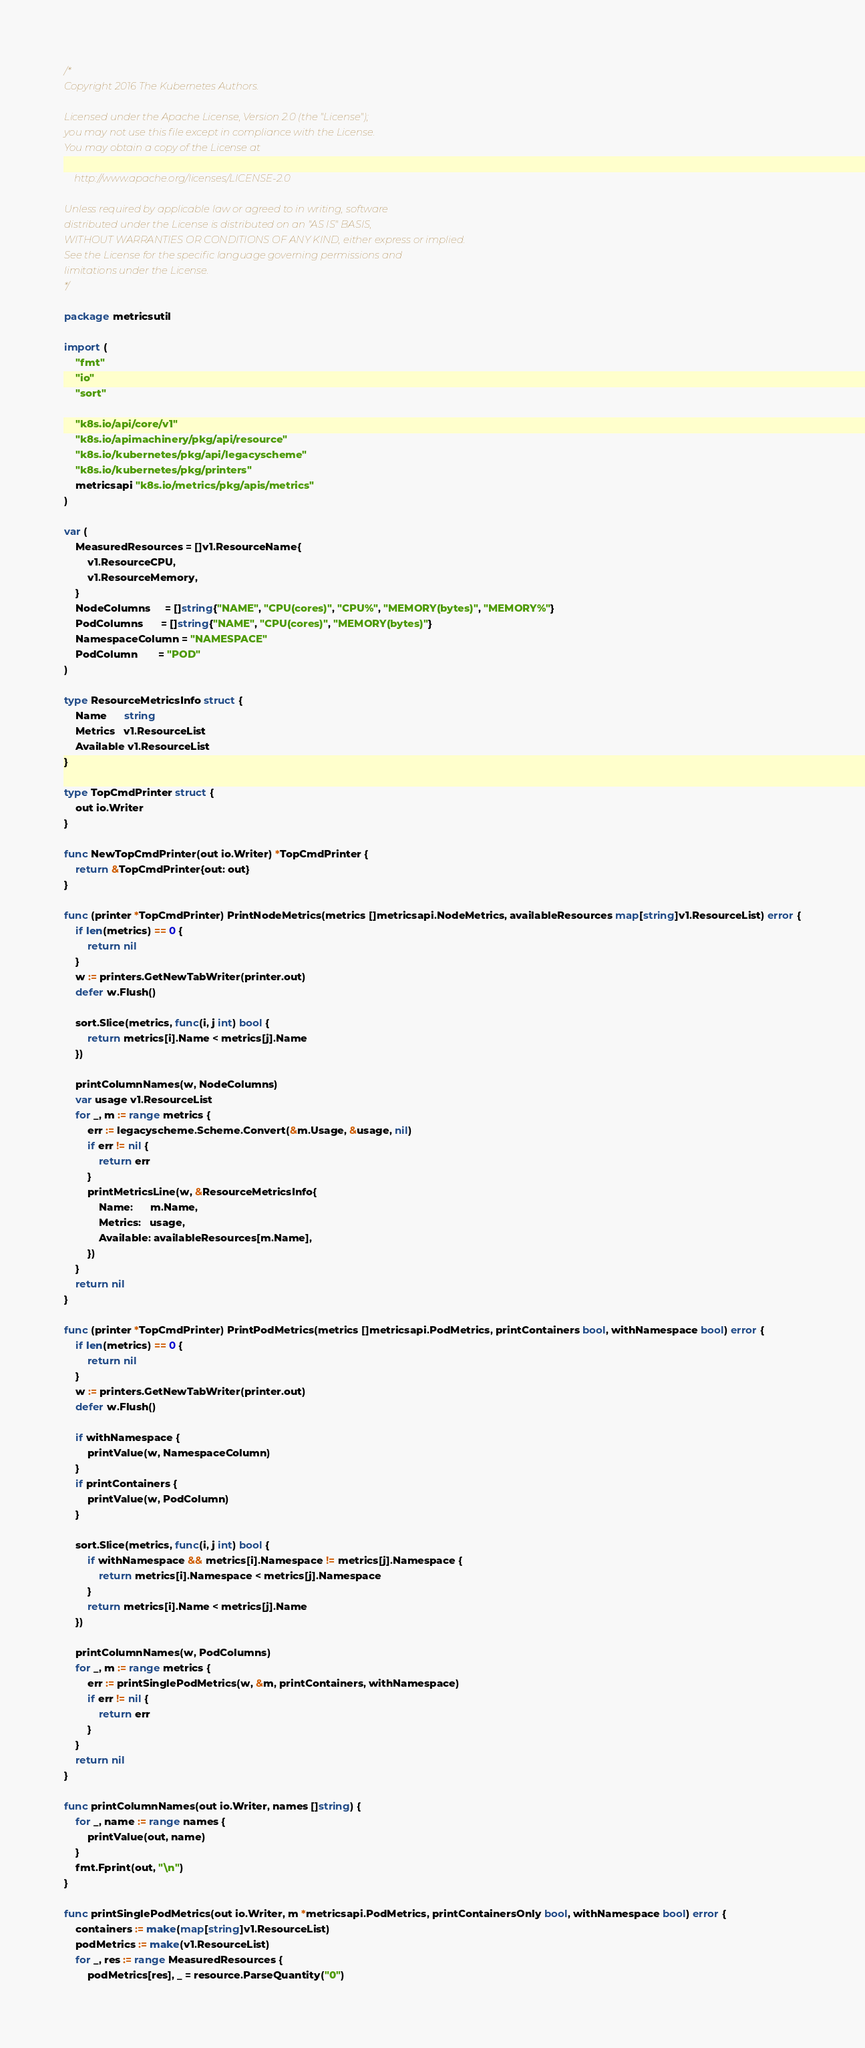Convert code to text. <code><loc_0><loc_0><loc_500><loc_500><_Go_>/*
Copyright 2016 The Kubernetes Authors.

Licensed under the Apache License, Version 2.0 (the "License");
you may not use this file except in compliance with the License.
You may obtain a copy of the License at

    http://www.apache.org/licenses/LICENSE-2.0

Unless required by applicable law or agreed to in writing, software
distributed under the License is distributed on an "AS IS" BASIS,
WITHOUT WARRANTIES OR CONDITIONS OF ANY KIND, either express or implied.
See the License for the specific language governing permissions and
limitations under the License.
*/

package metricsutil

import (
	"fmt"
	"io"
	"sort"

	"k8s.io/api/core/v1"
	"k8s.io/apimachinery/pkg/api/resource"
	"k8s.io/kubernetes/pkg/api/legacyscheme"
	"k8s.io/kubernetes/pkg/printers"
	metricsapi "k8s.io/metrics/pkg/apis/metrics"
)

var (
	MeasuredResources = []v1.ResourceName{
		v1.ResourceCPU,
		v1.ResourceMemory,
	}
	NodeColumns     = []string{"NAME", "CPU(cores)", "CPU%", "MEMORY(bytes)", "MEMORY%"}
	PodColumns      = []string{"NAME", "CPU(cores)", "MEMORY(bytes)"}
	NamespaceColumn = "NAMESPACE"
	PodColumn       = "POD"
)

type ResourceMetricsInfo struct {
	Name      string
	Metrics   v1.ResourceList
	Available v1.ResourceList
}

type TopCmdPrinter struct {
	out io.Writer
}

func NewTopCmdPrinter(out io.Writer) *TopCmdPrinter {
	return &TopCmdPrinter{out: out}
}

func (printer *TopCmdPrinter) PrintNodeMetrics(metrics []metricsapi.NodeMetrics, availableResources map[string]v1.ResourceList) error {
	if len(metrics) == 0 {
		return nil
	}
	w := printers.GetNewTabWriter(printer.out)
	defer w.Flush()

	sort.Slice(metrics, func(i, j int) bool {
		return metrics[i].Name < metrics[j].Name
	})

	printColumnNames(w, NodeColumns)
	var usage v1.ResourceList
	for _, m := range metrics {
		err := legacyscheme.Scheme.Convert(&m.Usage, &usage, nil)
		if err != nil {
			return err
		}
		printMetricsLine(w, &ResourceMetricsInfo{
			Name:      m.Name,
			Metrics:   usage,
			Available: availableResources[m.Name],
		})
	}
	return nil
}

func (printer *TopCmdPrinter) PrintPodMetrics(metrics []metricsapi.PodMetrics, printContainers bool, withNamespace bool) error {
	if len(metrics) == 0 {
		return nil
	}
	w := printers.GetNewTabWriter(printer.out)
	defer w.Flush()

	if withNamespace {
		printValue(w, NamespaceColumn)
	}
	if printContainers {
		printValue(w, PodColumn)
	}

	sort.Slice(metrics, func(i, j int) bool {
		if withNamespace && metrics[i].Namespace != metrics[j].Namespace {
			return metrics[i].Namespace < metrics[j].Namespace
		}
		return metrics[i].Name < metrics[j].Name
	})

	printColumnNames(w, PodColumns)
	for _, m := range metrics {
		err := printSinglePodMetrics(w, &m, printContainers, withNamespace)
		if err != nil {
			return err
		}
	}
	return nil
}

func printColumnNames(out io.Writer, names []string) {
	for _, name := range names {
		printValue(out, name)
	}
	fmt.Fprint(out, "\n")
}

func printSinglePodMetrics(out io.Writer, m *metricsapi.PodMetrics, printContainersOnly bool, withNamespace bool) error {
	containers := make(map[string]v1.ResourceList)
	podMetrics := make(v1.ResourceList)
	for _, res := range MeasuredResources {
		podMetrics[res], _ = resource.ParseQuantity("0")</code> 